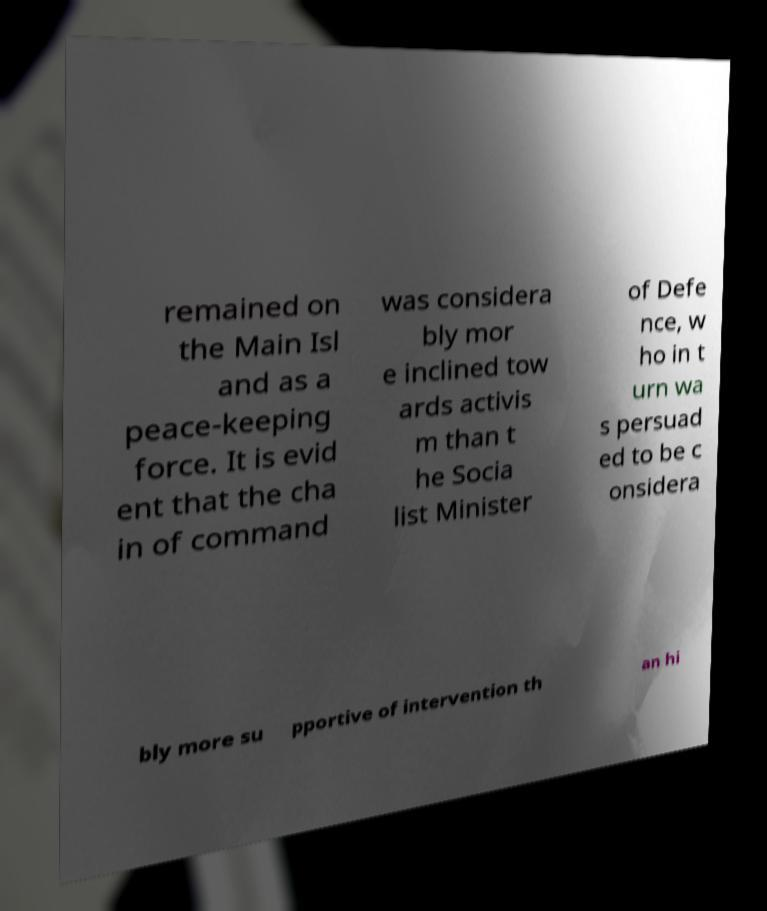Could you extract and type out the text from this image? remained on the Main Isl and as a peace-keeping force. It is evid ent that the cha in of command was considera bly mor e inclined tow ards activis m than t he Socia list Minister of Defe nce, w ho in t urn wa s persuad ed to be c onsidera bly more su pportive of intervention th an hi 